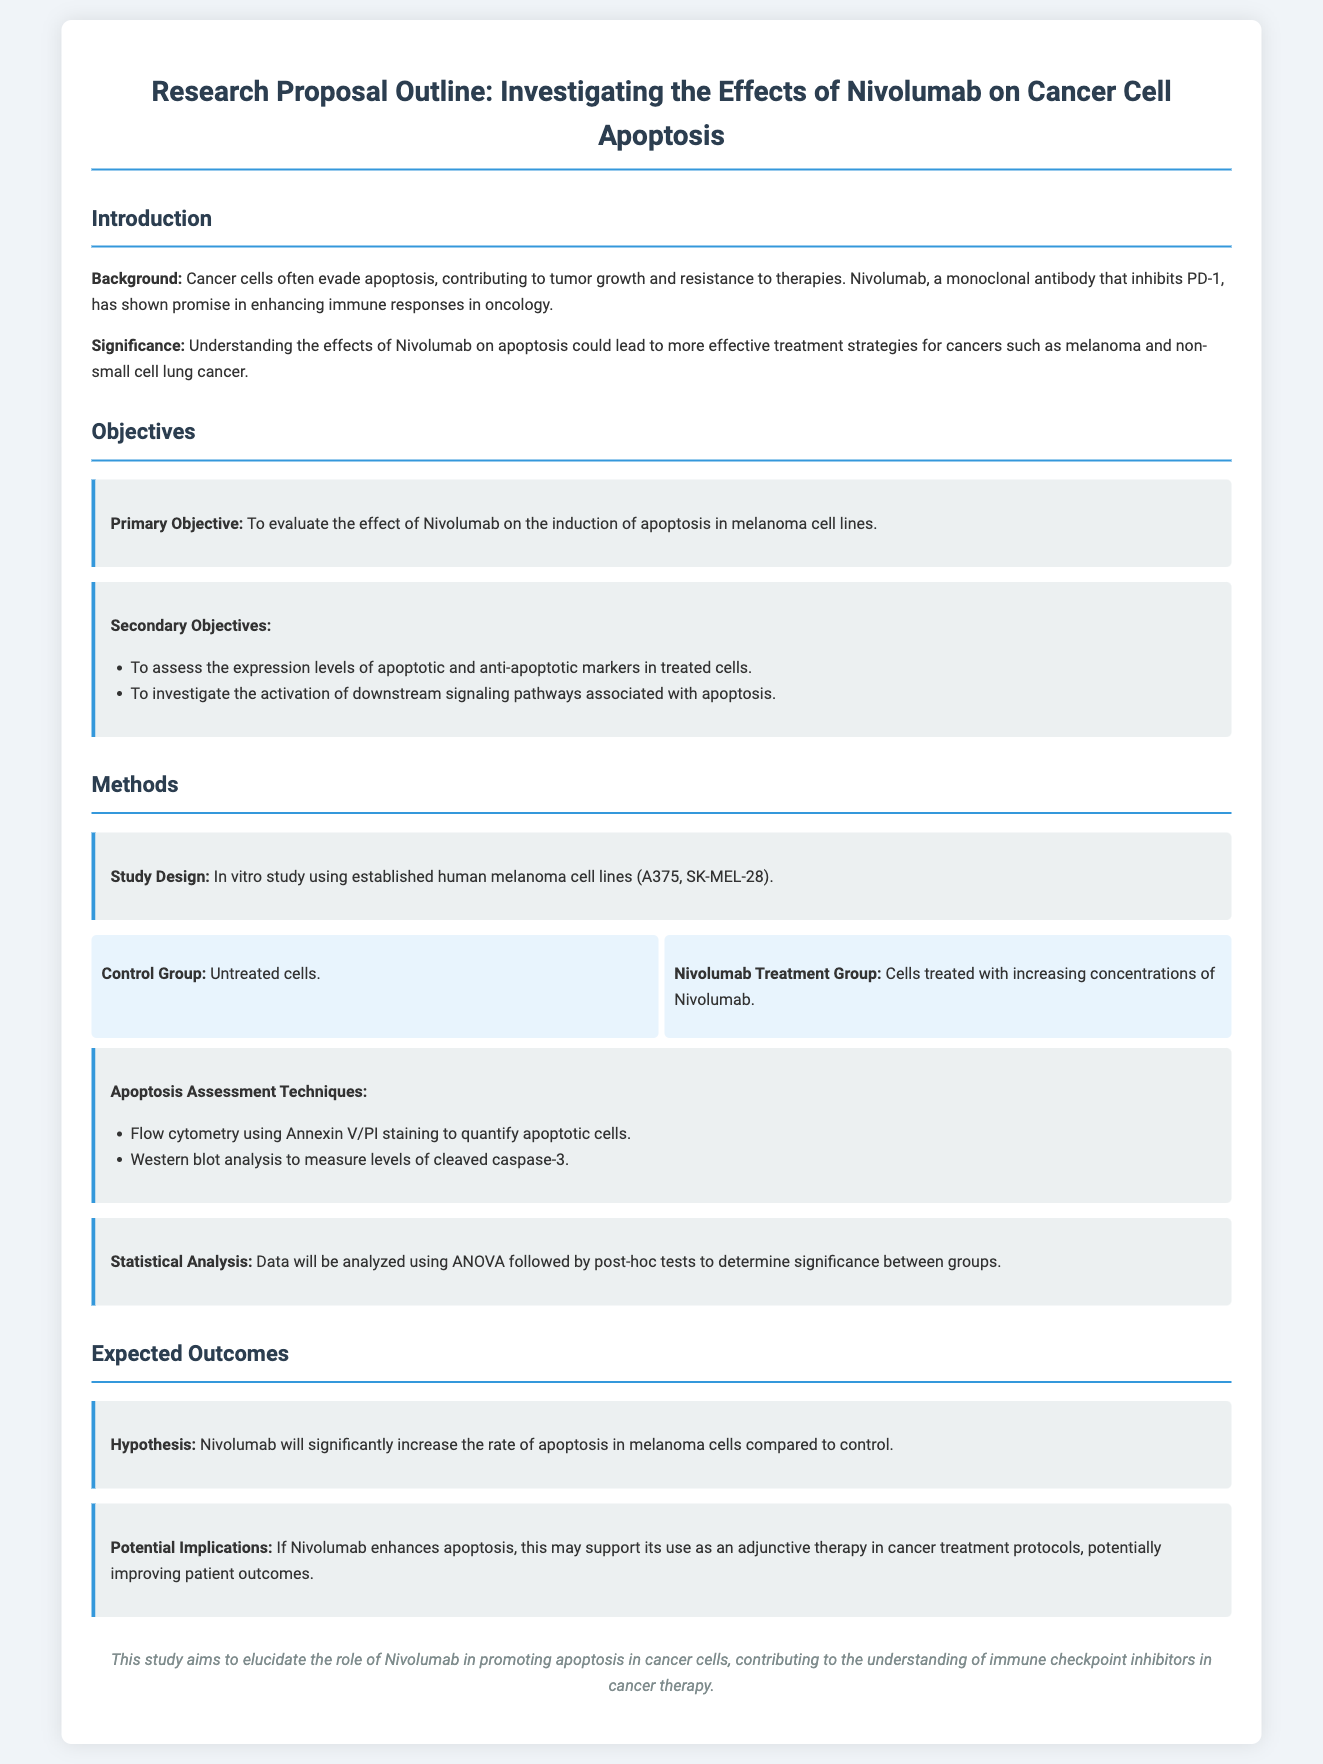what is the primary objective of the study? The primary objective is to evaluate the effect of Nivolumab on the induction of apoptosis in melanoma cell lines.
Answer: evaluate the effect of Nivolumab on the induction of apoptosis in melanoma cell lines what cell lines are used in the study? The study uses established human melanoma cell lines A375 and SK-MEL-28.
Answer: A375, SK-MEL-28 which treatment method is used for apoptosis assessment? Apoptosis assessment techniques include flow cytometry using Annexin V/PI staining and Western blot analysis.
Answer: flow cytometry using Annexin V/PI staining and Western blot analysis what statistical method will be used to analyze the data? The data will be analyzed using ANOVA followed by post-hoc tests.
Answer: ANOVA followed by post-hoc tests what is the expected outcome regarding Nivolumab's effect? Nivolumab is hypothesized to significantly increase the rate of apoptosis in melanoma cells compared to control.
Answer: significantly increase the rate of apoptosis in melanoma cells compared to control how does the study contribute to cancer therapy? The study aims to elucidate the role of Nivolumab in promoting apoptosis in cancer cells, contributing to the understanding of immune checkpoint inhibitors in cancer therapy.
Answer: understanding of immune checkpoint inhibitors in cancer therapy 